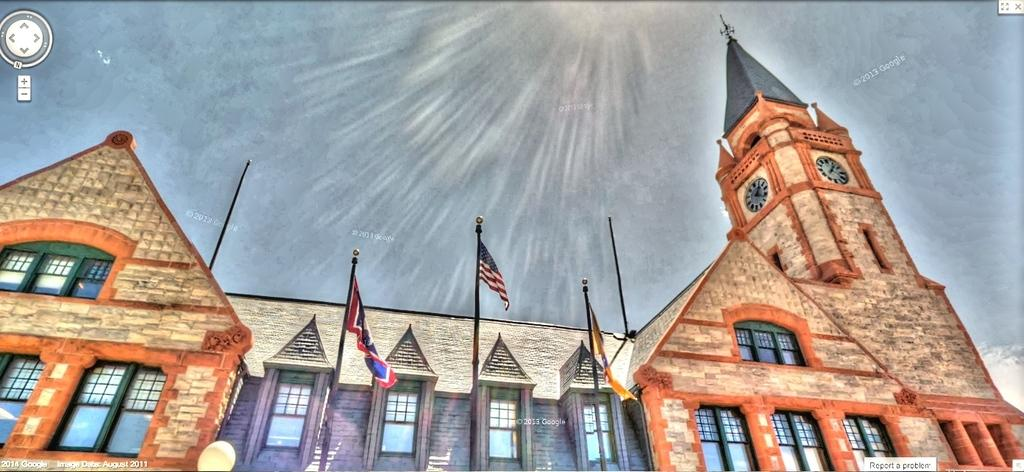What type of structure is visible in the image? There is a building in the image. What feature can be seen on the building? The building has windows. What other objects are present in the image? There are poles, clocks, and flags in the image. What is the color of the background in the image? The background of the image is grey. What type of wire can be seen connecting the clocks in the image? There is no wire connecting the clocks in the image. 